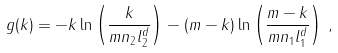<formula> <loc_0><loc_0><loc_500><loc_500>g ( k ) = - k \ln \left ( \frac { k } { m n _ { 2 } l _ { 2 } ^ { d } } \right ) - ( m - k ) \ln \left ( \frac { m - k } { m n _ { 1 } l _ { 1 } ^ { d } } \right ) \, ,</formula> 